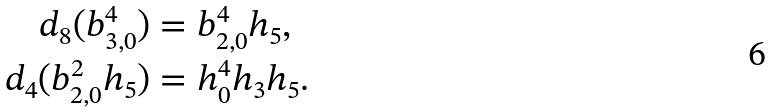Convert formula to latex. <formula><loc_0><loc_0><loc_500><loc_500>d _ { 8 } ( b _ { 3 , 0 } ^ { 4 } ) & = b _ { 2 , 0 } ^ { 4 } h _ { 5 } , \\ d _ { 4 } ( b _ { 2 , 0 } ^ { 2 } h _ { 5 } ) & = h _ { 0 } ^ { 4 } h _ { 3 } h _ { 5 } .</formula> 